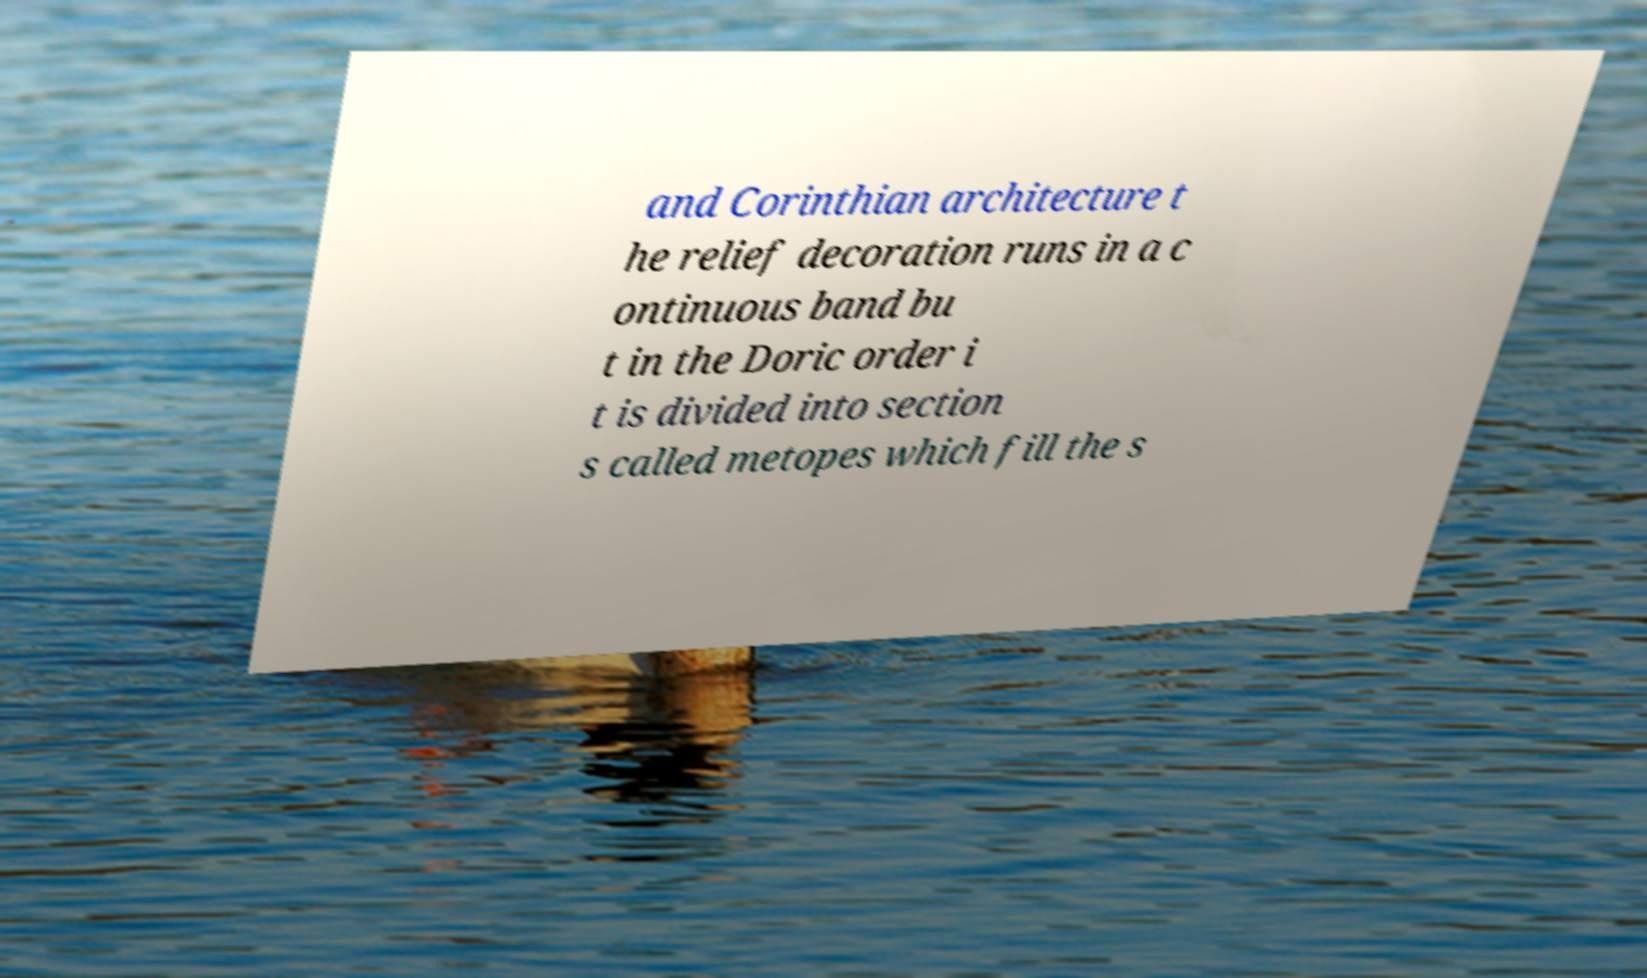Can you read and provide the text displayed in the image?This photo seems to have some interesting text. Can you extract and type it out for me? and Corinthian architecture t he relief decoration runs in a c ontinuous band bu t in the Doric order i t is divided into section s called metopes which fill the s 